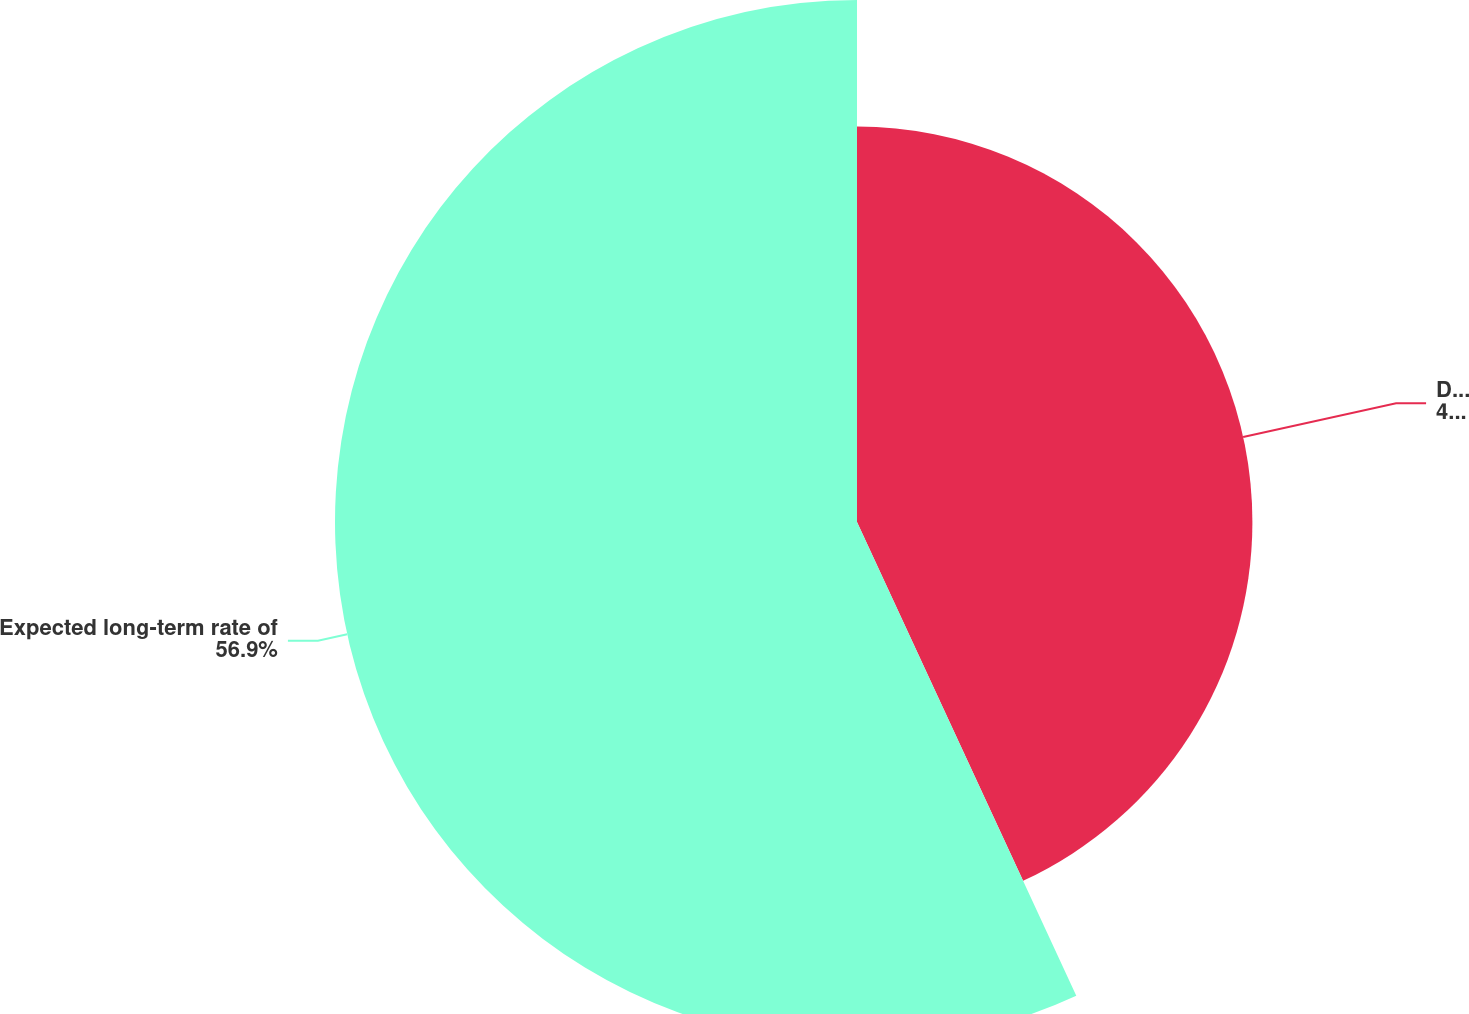<chart> <loc_0><loc_0><loc_500><loc_500><pie_chart><fcel>Discount rate<fcel>Expected long-term rate of<nl><fcel>43.1%<fcel>56.9%<nl></chart> 